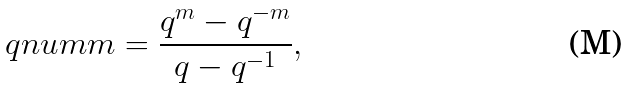<formula> <loc_0><loc_0><loc_500><loc_500>\ q n u m { m } = \frac { q ^ { m } - q ^ { - m } } { q - q ^ { - 1 } } ,</formula> 